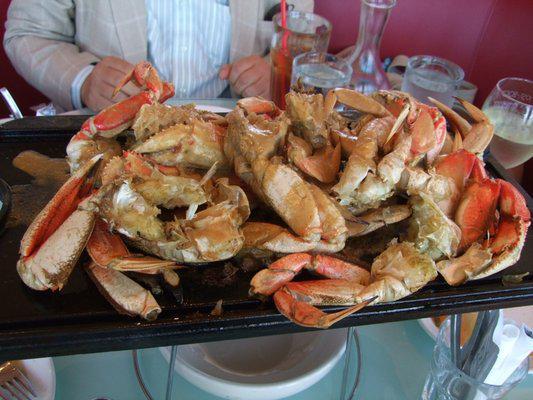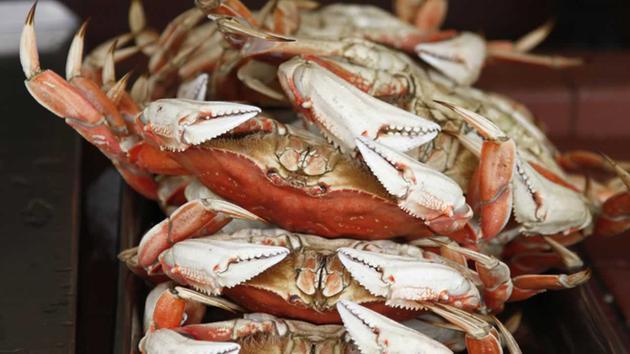The first image is the image on the left, the second image is the image on the right. Evaluate the accuracy of this statement regarding the images: "At least one beverage in a clear glass is on the right of a pile of seafood with claws in one image.". Is it true? Answer yes or no. Yes. The first image is the image on the left, the second image is the image on the right. Examine the images to the left and right. Is the description "The crabs in one of the images are being served with drinks." accurate? Answer yes or no. Yes. 